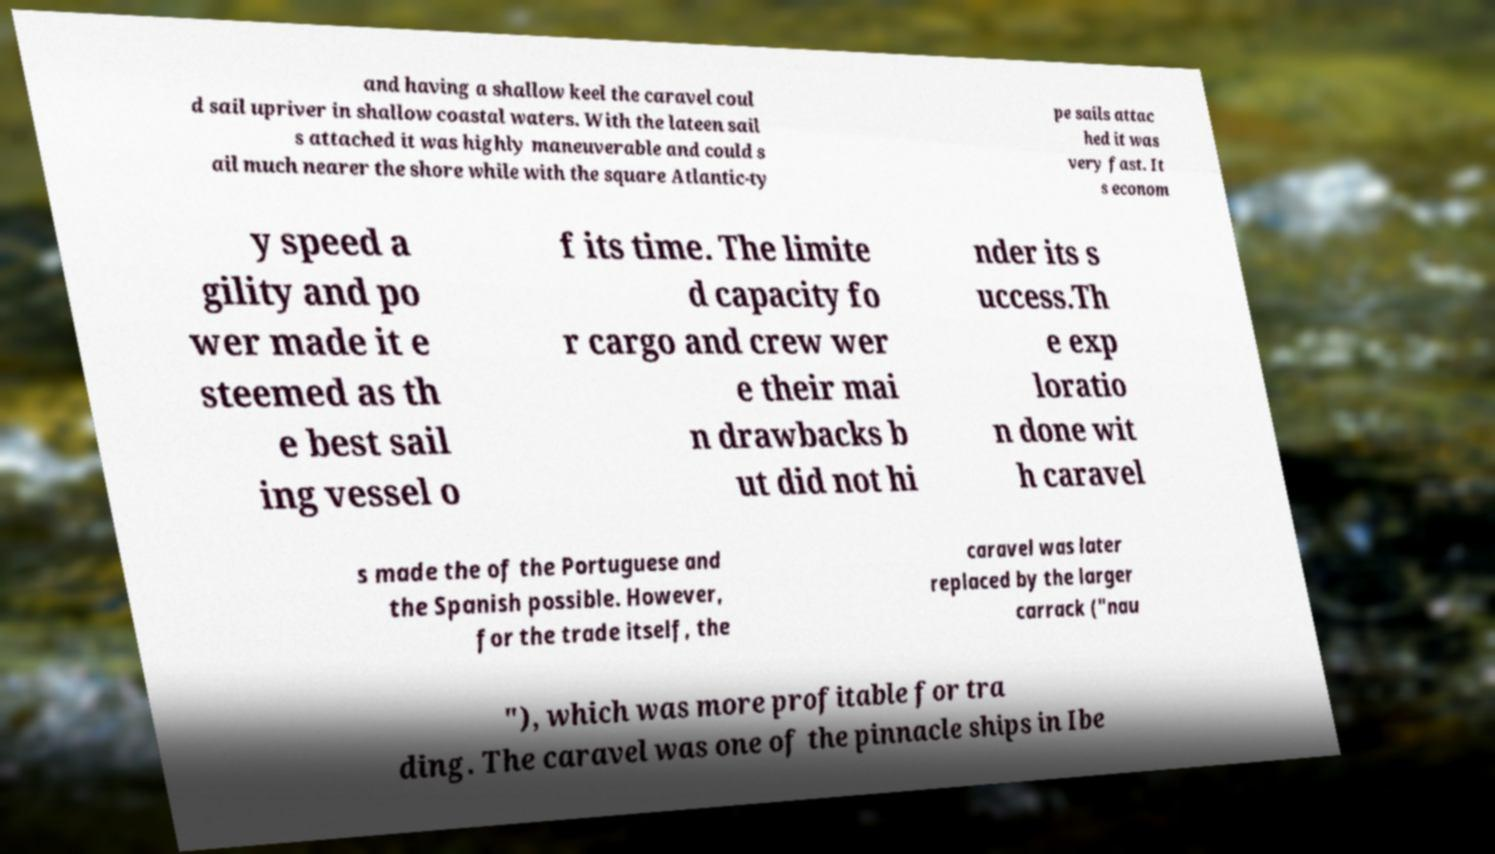For documentation purposes, I need the text within this image transcribed. Could you provide that? and having a shallow keel the caravel coul d sail upriver in shallow coastal waters. With the lateen sail s attached it was highly maneuverable and could s ail much nearer the shore while with the square Atlantic-ty pe sails attac hed it was very fast. It s econom y speed a gility and po wer made it e steemed as th e best sail ing vessel o f its time. The limite d capacity fo r cargo and crew wer e their mai n drawbacks b ut did not hi nder its s uccess.Th e exp loratio n done wit h caravel s made the of the Portuguese and the Spanish possible. However, for the trade itself, the caravel was later replaced by the larger carrack ("nau "), which was more profitable for tra ding. The caravel was one of the pinnacle ships in Ibe 